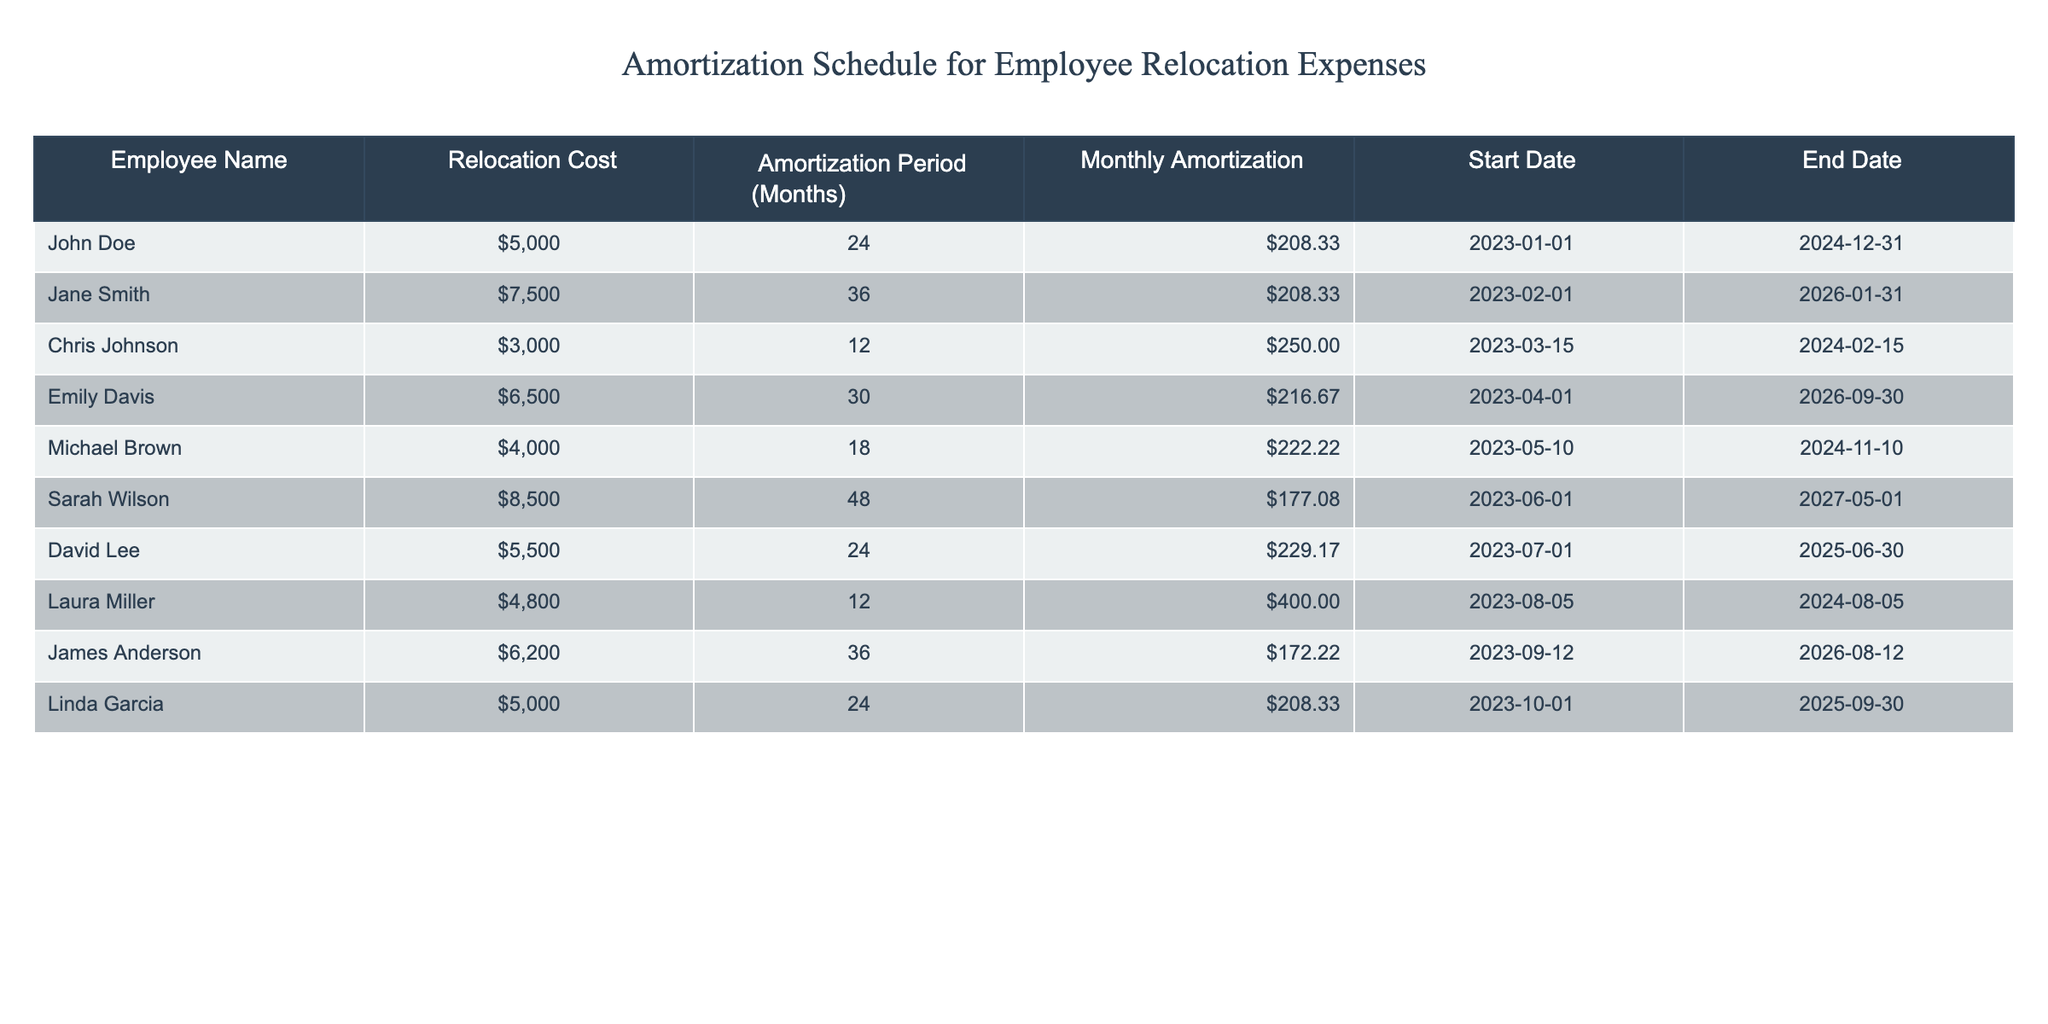What is the total relocation cost for all employees? To find the total relocation cost, I will sum the 'Relocation Cost' values from each employee. The sum is 5000 + 7500 + 3000 + 6500 + 4000 + 8500 + 5500 + 4800 + 6200 + 5000 = 40000.
Answer: 40000 Which employee has the highest monthly amortization amount? I will compare the 'Monthly Amortization' values for each employee. The highest value is 400.00 from Laura Miller.
Answer: Laura Miller How many employees have an amortization period greater than 24 months? I will count the number of employees whose 'Amortization Period' is greater than 24 months. The relevant rows are: Jane Smith (36), Emily Davis (30), Sarah Wilson (48), and James Anderson (36), totaling 4 employees.
Answer: 4 What is the average monthly amortization for all employees? I will first sum up the 'Monthly Amortization' values: 208.33 + 208.33 + 250.00 + 216.67 + 222.22 + 177.08 + 229.17 + 400.00 + 172.22 + 208.33 = 2089.67, then divide by the number of employees (10): 2089.67 / 10 = 208.97.
Answer: 208.97 Is it true that David Lee's relocation cost is less than Sarah Wilson's? I will compare the 'Relocation Cost' of David Lee (5500) and Sarah Wilson (8500). Since 5500 is less than 8500, it is true.
Answer: Yes Which employees have an amortization period of exactly 24 months? I will filter the table for employees with an 'Amortization Period' of 24 months. The employees are John Doe and Linda Garcia.
Answer: John Doe, Linda Garcia If Emily Davis's relocation cost were reduced by 1000, what would be her new monthly amortization? Emily Davis's current relocation cost is 6500. If reduced by 1000, the new cost would be 5500. The monthly amortization would then be calculated by dividing 5500 by 30 (the amortization period): 5500 / 30 = 183.33.
Answer: 183.33 How many months does Chris Johnson have left until his amortization period ends? Chris Johnson's amortization period starts on 2023-03-15 and ends on 2024-02-15, which totals 12 months. Since he has completed 7 months by October 2023, he has 5 months left.
Answer: 5 What is the difference in total amortization between Sarah Wilson and Michael Brown? I will sum the 'Monthly Amortization' over their respective amortization periods: Sarah Wilson (177.08 * 48) = 8499.84 and Michael Brown (222.22 * 18) = 4000. Therefore, the difference is 8499.84 - 4000 = 4499.84.
Answer: 4499.84 